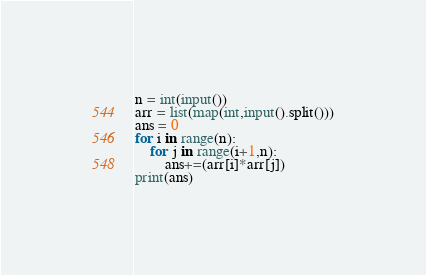<code> <loc_0><loc_0><loc_500><loc_500><_Python_>n = int(input())
arr = list(map(int,input().split()))
ans = 0
for i in range(n):
    for j in range(i+1,n):
        ans+=(arr[i]*arr[j])
print(ans)</code> 